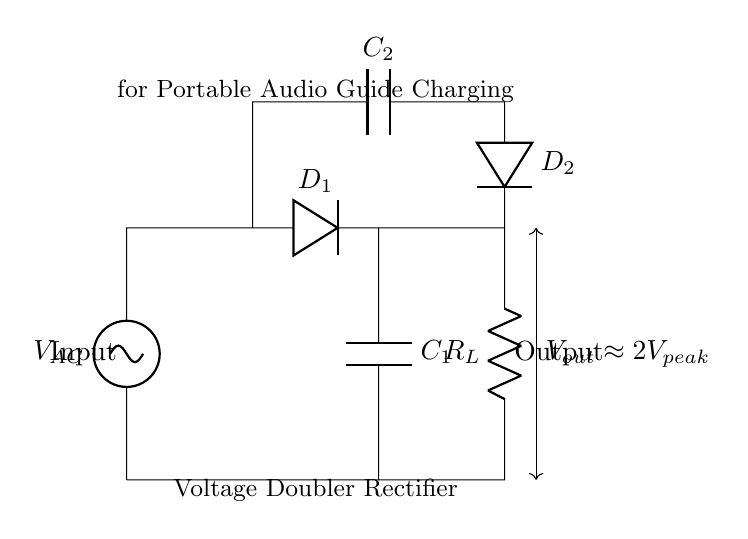What type of circuit is this? This circuit is identified as a voltage doubler rectifier. A voltage doubler is designed to increase the output voltage from the input AC signal by utilizing two diodes and two capacitors. The labeling on the diagram also confirms this designation.
Answer: voltage doubler rectifier How many diodes are in the circuit? There are two diodes present in the circuit, labeled as D1 and D2. Each diode conducts current during alternating cycles of the input AC voltage, allowing for rectification of the waveform.
Answer: two What is the purpose of the capacitors in this circuit? The capacitors (C1 and C2) in this voltage doubler rectifier serve to store charge. Capacitor C1 holds charge from the first diode's conduction, while C2 allows for further voltage increase when C1 discharges, effectively doubling the voltage output.
Answer: charge storage What is the approximate output voltage of the circuit? The diagram indicates that the output voltage (Vout) is approximately double the peak input voltage (Vpeak). This is a key characteristic of the voltage doubler rectifier, where the effective output voltage is boosted.
Answer: 2Vpeak What is the role of the load resistor in this circuit? The load resistor (RL) is used to represent the external device or load that will utilize the rectified output voltage. It absorbs the current produced by the rectifier circuit, demonstrating how the rectifier powers devices such as portable audio guides.
Answer: load resistor What happens to the output voltage when the input AC voltage increases? If the input AC voltage increases, the peak voltage applied to the rectifier rises as well. Since the output is approximately two times the peak input voltage, the output voltage will increase correspondingly, enhancing the charge supplied to the connected devices.
Answer: increases proportionally 